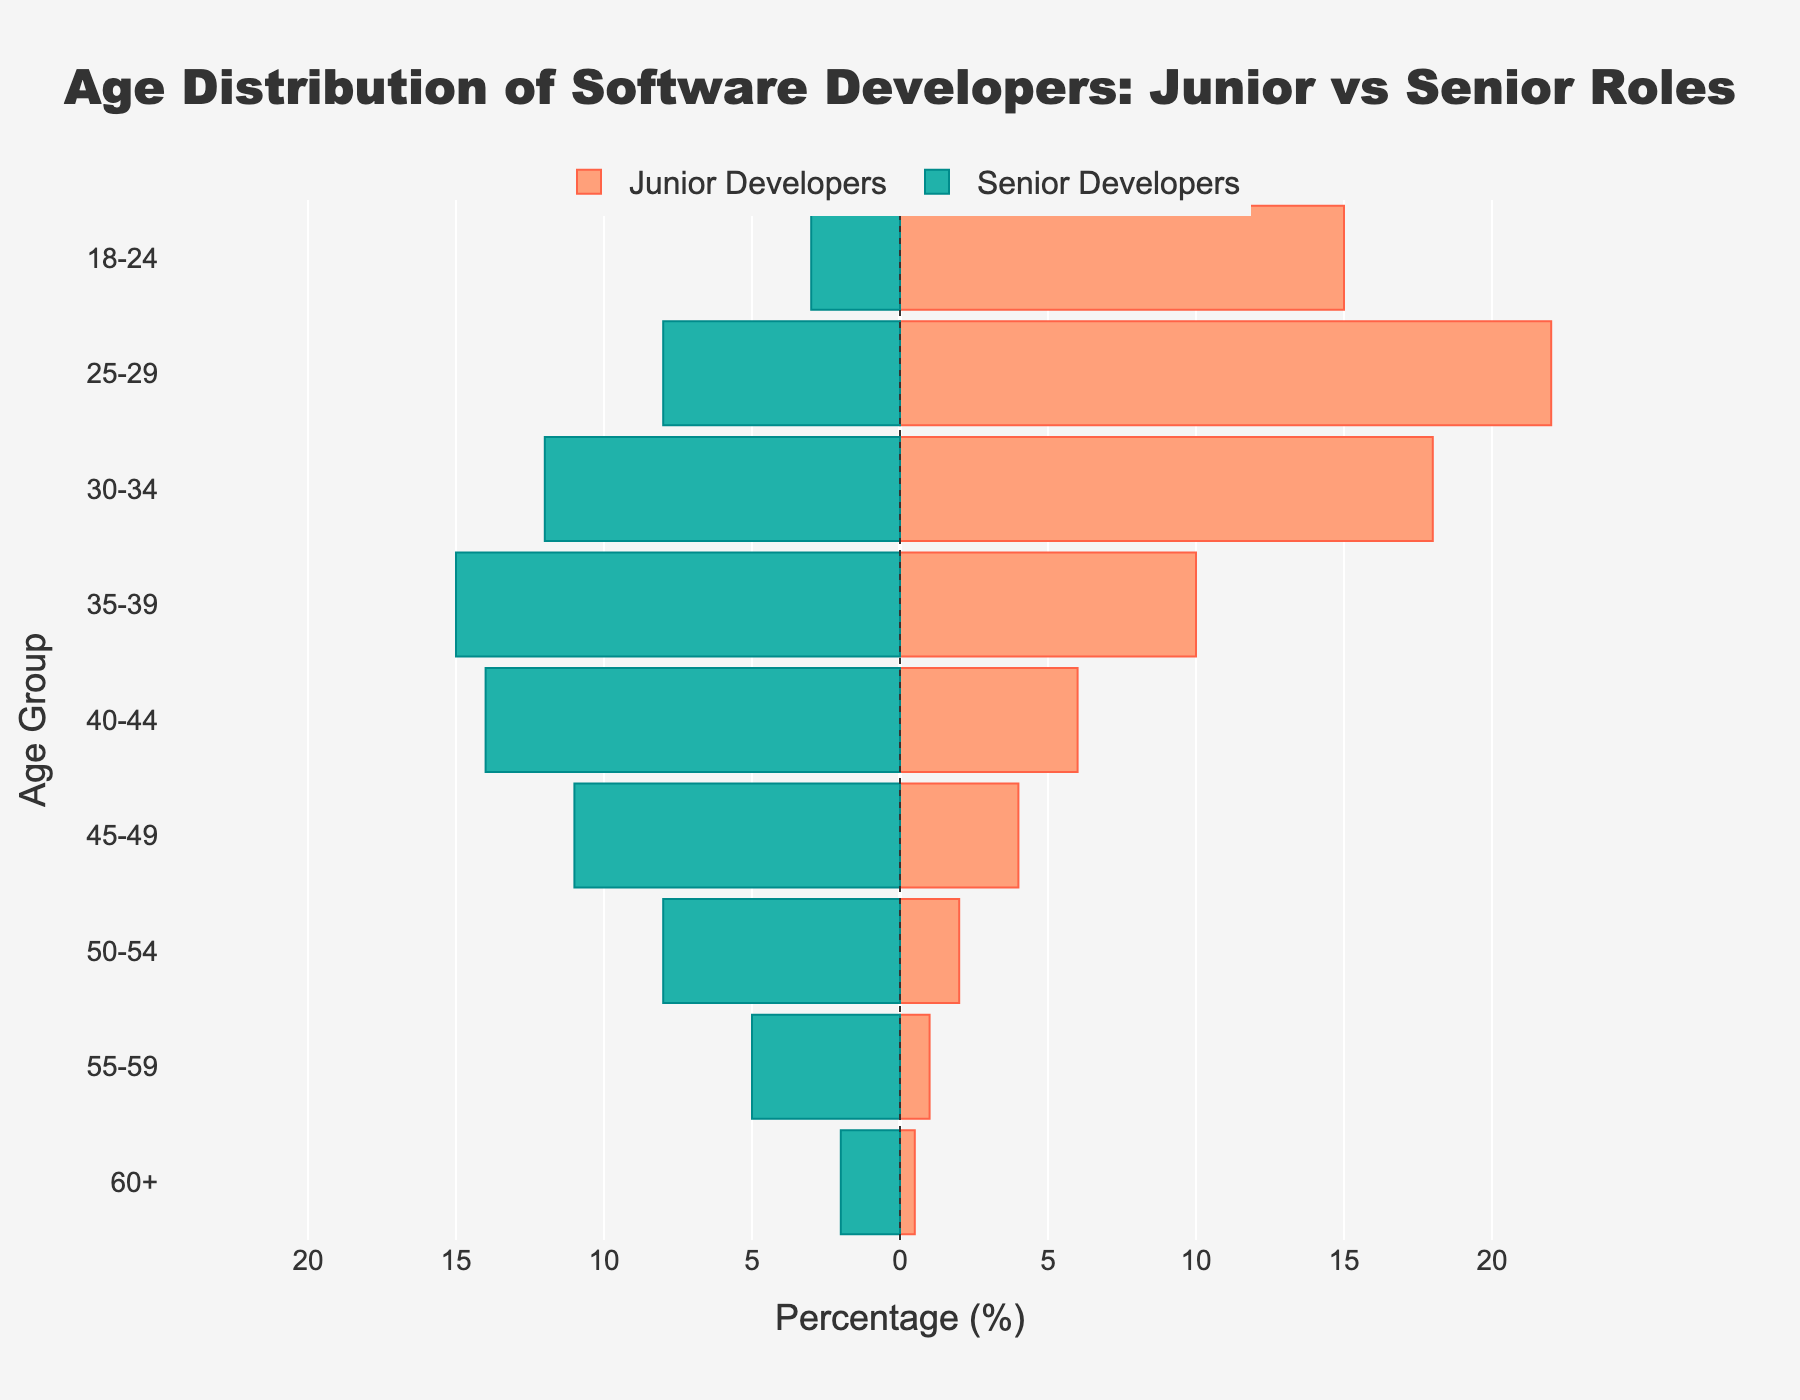What is the title of the figure? The title of the figure can be found at the top of the plot. It usually describes the content and purpose of the figure. Here, the title is "Age Distribution of Software Developers: Junior vs Senior Roles".
Answer: Age Distribution of Software Developers: Junior vs Senior Roles What age group has the highest percentage of junior developers? To find the age group with the highest percentage of junior developers, look at the bars on the right side of the plot (since junior developers are on that side) and identify which bar is the longest. The longest bar is for the 25-29 age group.
Answer: 25-29 How many percentage points separate the 18-24 and 25-29 age groups among senior developers? First, find the percentages for the 18-24 and 25-29 age groups among senior developers. The figure shows -3% for 18-24 and -8% for 25-29. Calculate the absolute difference:
Answer: 5 In which age group are the senior developers least represented? To determine in which age group senior developers are least represented, look at the bars on the left side of the plot and identify the shortest bar. The shortest bar is for the 60+ age group.
Answer: 60+ Compare the total percentage of junior developers to senior developers for the 35-39 age group. Which is higher? Find the percentages for the 35-39 age group for both junior and senior developers. The figure shows 10% for junior developers and -15% for senior developers. Since the absolute value is considered, 15% (senior developers) is higher.
Answer: Senior Developers Which age group shows a significant decline in the percentage of senior developers compared to the adjacent younger age group? Look at the age groups with senior developers' bars (left side) and compare the height of each bar with the next younger age group (above it). The transition between 25-29 and 30-34 shows a significant decline from -8% to -12%.
Answer: 30-34 What percentage of developers aged 45-49 are junior developers, and how does it compare to those senior developers in the same age group? Find the percentage for the 45-49 age group in both junior and senior categories. The figure shows 4% for junior developers and -11% for senior developers. 4% junior developers compared to 11% senior developers.
Answer: 4% vs. 11% Is the percentage of senior developers aged 50-54 higher or lower than those aged 55-59? Look at the bars for the 50-54 and 55-59 age groups on the left side of the plot. The percentages are -8% for 50-54 and -5% for 55-59. Since the absolute value is considered, -8% is higher than -5%.
Answer: Higher How does the age distribution of senior developers change as the age increases beyond 40? Look at the bars on the left side of the plot for age groups 40-44 and older. The length of the bars shows the increasing seniority: -14% (40-44), -11% (45-49), -8% (50-54), and -5% (55-59), and decreases to -2% for 60+.
Answer: Decreases 